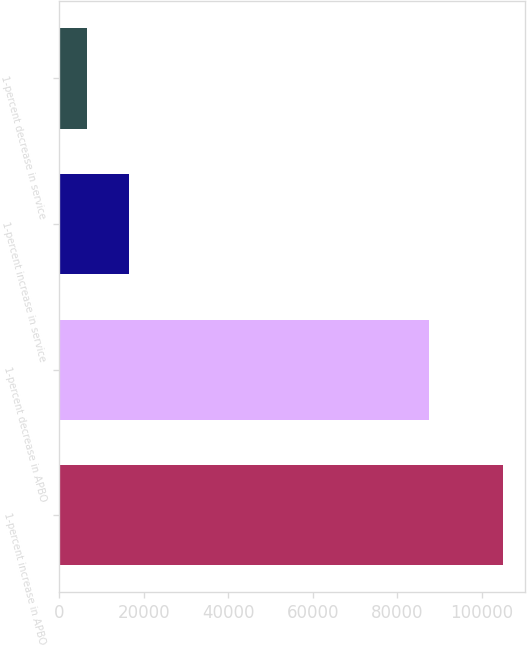Convert chart. <chart><loc_0><loc_0><loc_500><loc_500><bar_chart><fcel>1-percent increase in APBO<fcel>1-percent decrease in APBO<fcel>1-percent increase in service<fcel>1-percent decrease in service<nl><fcel>104967<fcel>87450<fcel>16523.1<fcel>6696<nl></chart> 